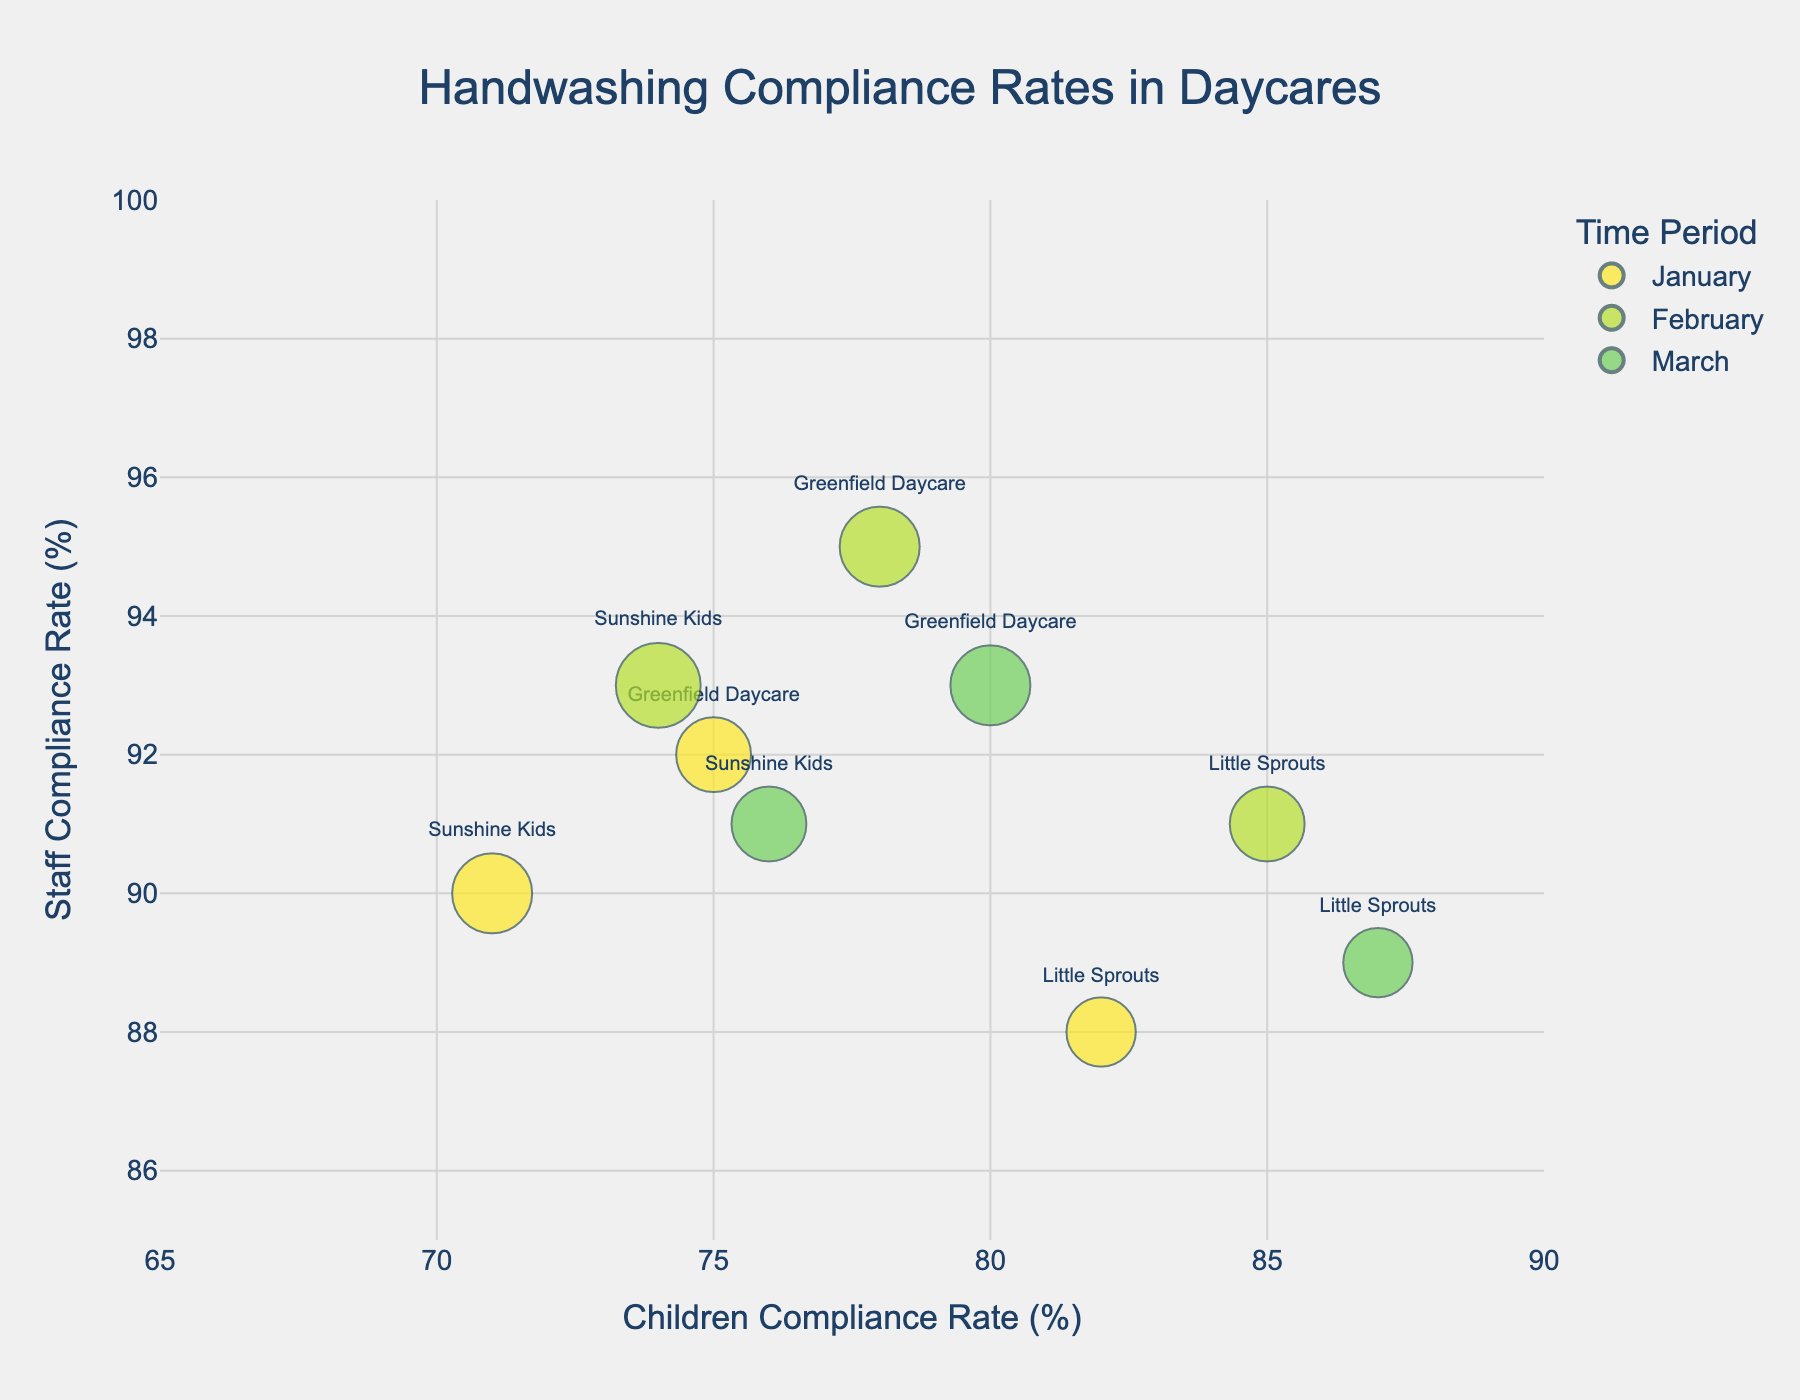What is the title of the chart? The title is usually located at the top of the chart and provides a summary of what the chart represents. In this case, it reads "Handwashing Compliance Rates in Daycares".
Answer: Handwashing Compliance Rates in Daycares What are the ranges for the x-axis and y-axis? The ranges can be seen by looking at the minimum and maximum values on each axis. The x-axis ranges from 65 to 90, and the y-axis ranges from 85 to 100.
Answer: x-axis: 65 to 90, y-axis: 85 to 100 Which entity has the highest Children's Compliance Rate in January? First, look at the bubbles color-coded for the January time period. Check the x-axis values for these bubbles to find the highest compliance rate. In January, Little Sprouts has the highest Children's Compliance Rate at 82%.
Answer: Little Sprouts Comparing Greenfield Daycare over time, what is the trend in Children's Compliance Rate? Trace Greenfield Daycare's bubbles across the three time periods. In January, it’s 75%, in February, it's 78%, and in March, it’s 80%. The trend shows an increasing Children's Compliance Rate over time.
Answer: Increasing Which time period has the largest bubble for Sunshine Kids? The size of the bubbles represents the Importance Score. Check the three bubbles for Sunshine Kids and compare their sizes. The largest bubble for Sunshine Kids is in February, reflecting an Importance Score of 9.
Answer: February How does Staff Compliance Rate change for Little Sprouts from January to March? Check the y-values for Little Sprouts across the time periods. In January, it’s 88%, in February, it’s 91%, and in March, it’s 89%. The staff compliance rate increases from January to February and slightly decreases in March.
Answer: Increases from Jan to Feb, decreases in Mar What is the difference in Children's Compliance Rates between January and March for Sunshine Kids? Find the x-values for Sunshine Kids in January and March. In January, it’s 71%, and in March, it’s 76%. Subtract the January rate from the March rate: 76% - 71% = 5%.
Answer: 5% Which daycare has the highest Staff Compliance Rate in February? Identify the bubbles for February and check their y-values to find the highest rate. Sunshine Kids has the highest Staff Compliance Rate in February at 93%.
Answer: Sunshine Kids What's the average Children's Compliance Rate in March across all entities? Look at the x-values for each entity in March: Greenfield Daycare (80%), Little Sprouts (87%), and Sunshine Kids (76%). Calculate the mean: (80 + 87 + 76) / 3 = 81%.
Answer: 81% Which entity in which month has an Importance Score of 8? Examine all the bubbles and check their sizes, which represent the Importance Score of 8. Greenfield Daycare in February and March, and Sunshine Kids in January have an Importance Score of 8.
Answer: Greenfield Daycare in Feb and Mar, Sunshine Kids in Jan 